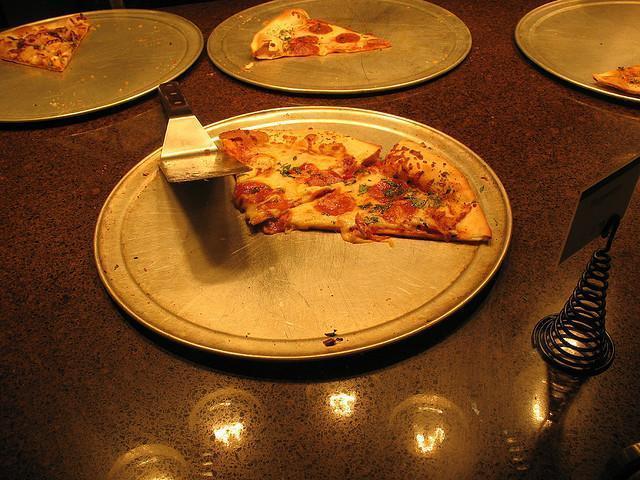How many pieces of pizza are there?
Give a very brief answer. 5. How many pizzas are in the photo?
Give a very brief answer. 3. How many people are shown?
Give a very brief answer. 0. 